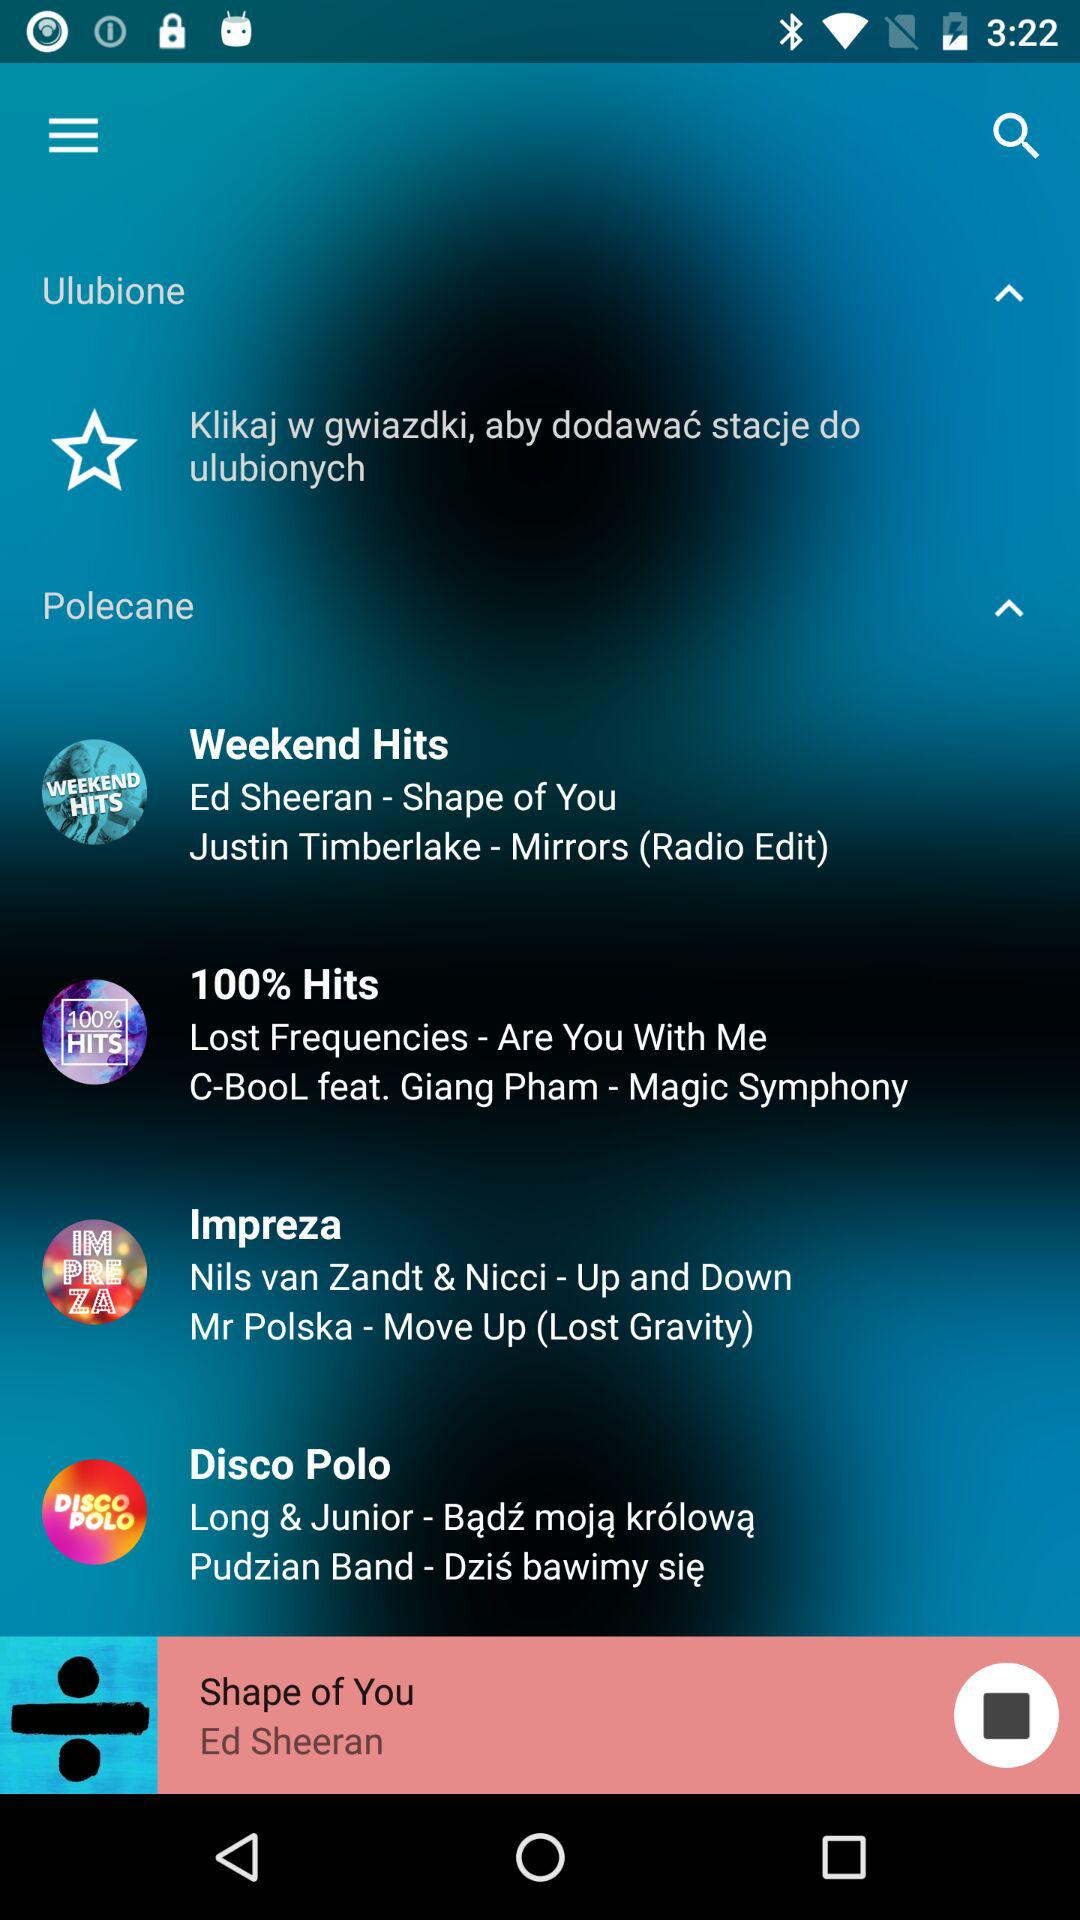Who is the singer of the song "Are You With Me"? The singer of the song "Are You With Me" is C-BooL feat. Giang Pham. 